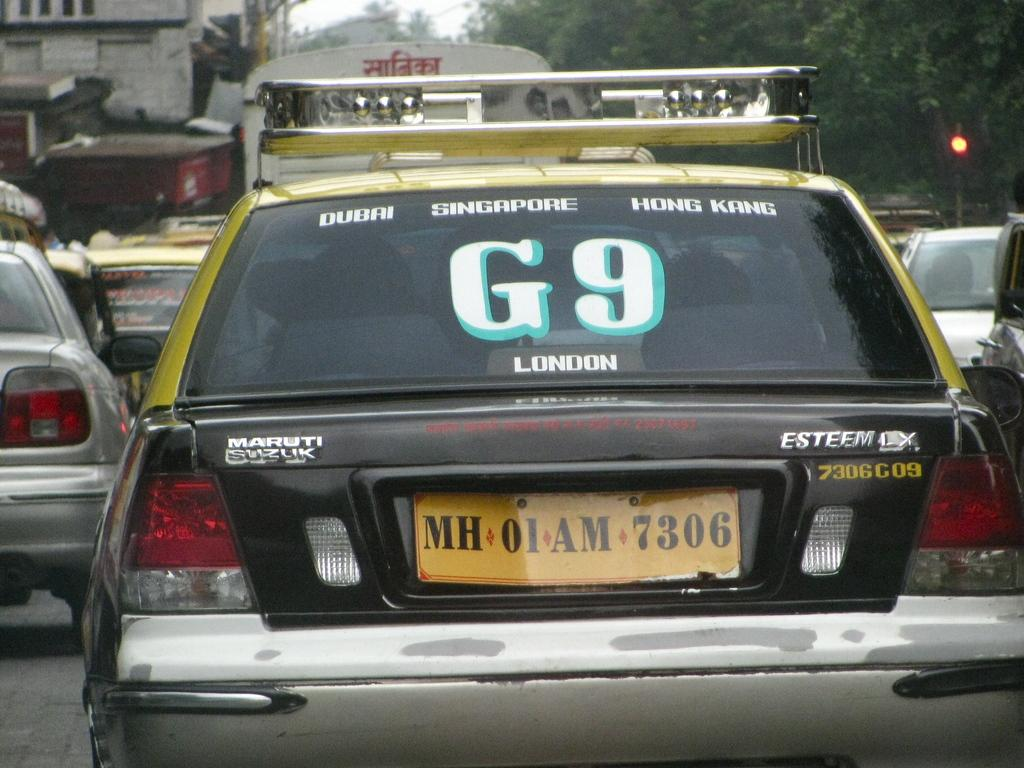<image>
Summarize the visual content of the image. A car has stickers in the back window that say G9 Singapore and Hong Kong. 